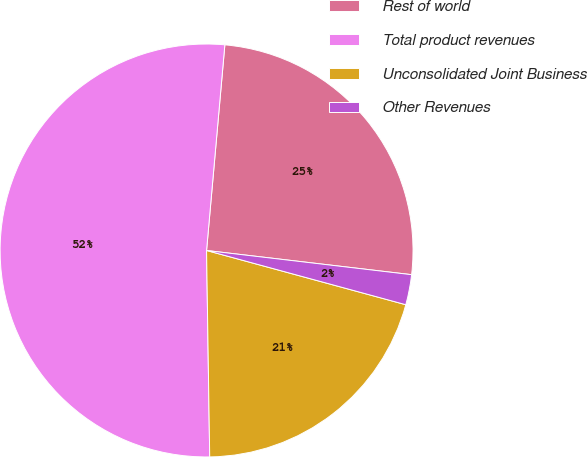<chart> <loc_0><loc_0><loc_500><loc_500><pie_chart><fcel>Rest of world<fcel>Total product revenues<fcel>Unconsolidated Joint Business<fcel>Other Revenues<nl><fcel>25.46%<fcel>51.66%<fcel>20.53%<fcel>2.36%<nl></chart> 